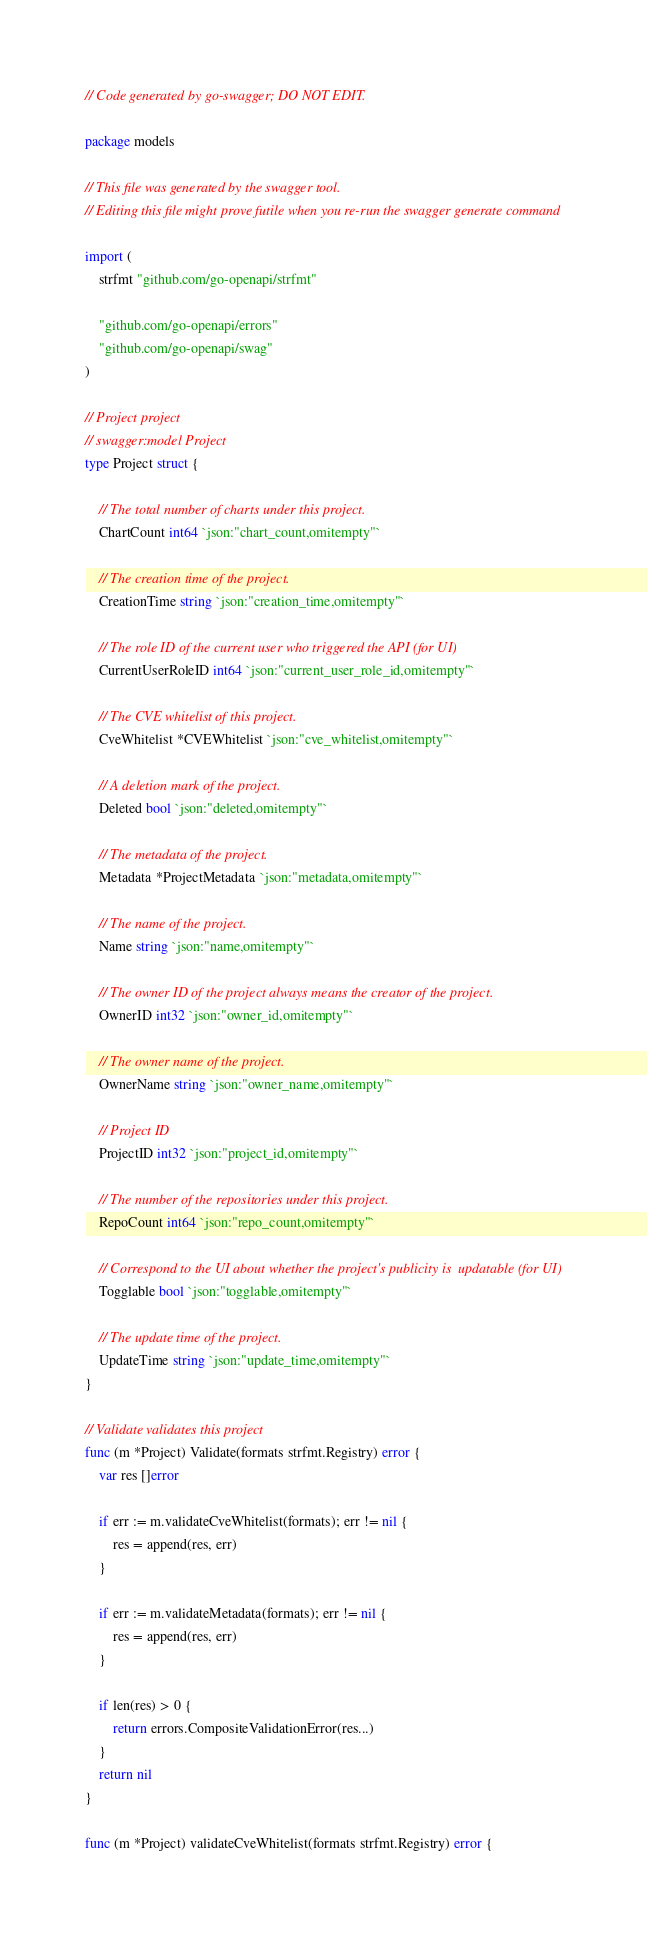Convert code to text. <code><loc_0><loc_0><loc_500><loc_500><_Go_>// Code generated by go-swagger; DO NOT EDIT.

package models

// This file was generated by the swagger tool.
// Editing this file might prove futile when you re-run the swagger generate command

import (
	strfmt "github.com/go-openapi/strfmt"

	"github.com/go-openapi/errors"
	"github.com/go-openapi/swag"
)

// Project project
// swagger:model Project
type Project struct {

	// The total number of charts under this project.
	ChartCount int64 `json:"chart_count,omitempty"`

	// The creation time of the project.
	CreationTime string `json:"creation_time,omitempty"`

	// The role ID of the current user who triggered the API (for UI)
	CurrentUserRoleID int64 `json:"current_user_role_id,omitempty"`

	// The CVE whitelist of this project.
	CveWhitelist *CVEWhitelist `json:"cve_whitelist,omitempty"`

	// A deletion mark of the project.
	Deleted bool `json:"deleted,omitempty"`

	// The metadata of the project.
	Metadata *ProjectMetadata `json:"metadata,omitempty"`

	// The name of the project.
	Name string `json:"name,omitempty"`

	// The owner ID of the project always means the creator of the project.
	OwnerID int32 `json:"owner_id,omitempty"`

	// The owner name of the project.
	OwnerName string `json:"owner_name,omitempty"`

	// Project ID
	ProjectID int32 `json:"project_id,omitempty"`

	// The number of the repositories under this project.
	RepoCount int64 `json:"repo_count,omitempty"`

	// Correspond to the UI about whether the project's publicity is  updatable (for UI)
	Togglable bool `json:"togglable,omitempty"`

	// The update time of the project.
	UpdateTime string `json:"update_time,omitempty"`
}

// Validate validates this project
func (m *Project) Validate(formats strfmt.Registry) error {
	var res []error

	if err := m.validateCveWhitelist(formats); err != nil {
		res = append(res, err)
	}

	if err := m.validateMetadata(formats); err != nil {
		res = append(res, err)
	}

	if len(res) > 0 {
		return errors.CompositeValidationError(res...)
	}
	return nil
}

func (m *Project) validateCveWhitelist(formats strfmt.Registry) error {
</code> 